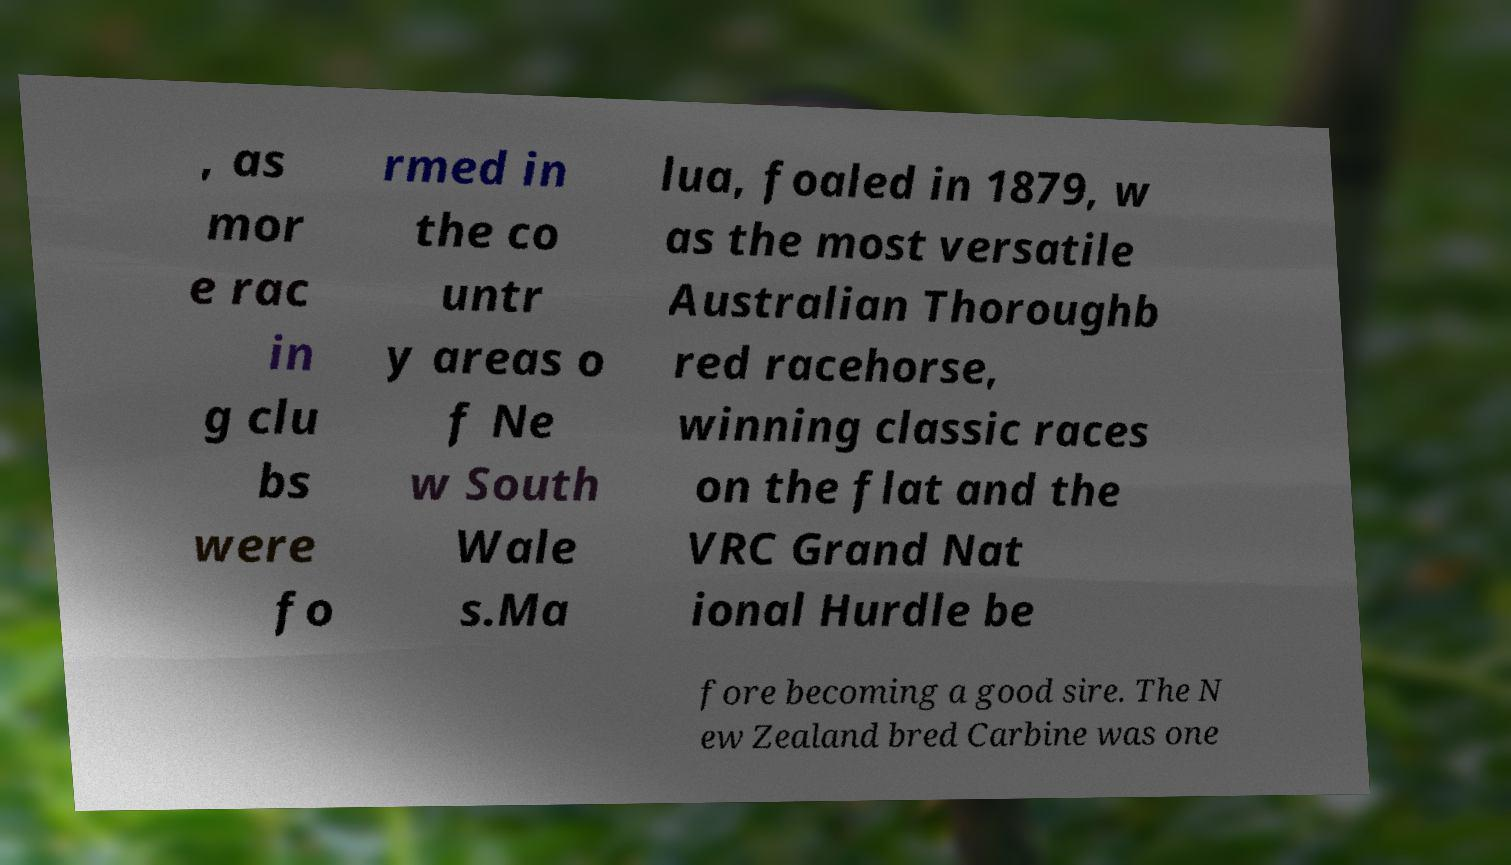Please identify and transcribe the text found in this image. , as mor e rac in g clu bs were fo rmed in the co untr y areas o f Ne w South Wale s.Ma lua, foaled in 1879, w as the most versatile Australian Thoroughb red racehorse, winning classic races on the flat and the VRC Grand Nat ional Hurdle be fore becoming a good sire. The N ew Zealand bred Carbine was one 